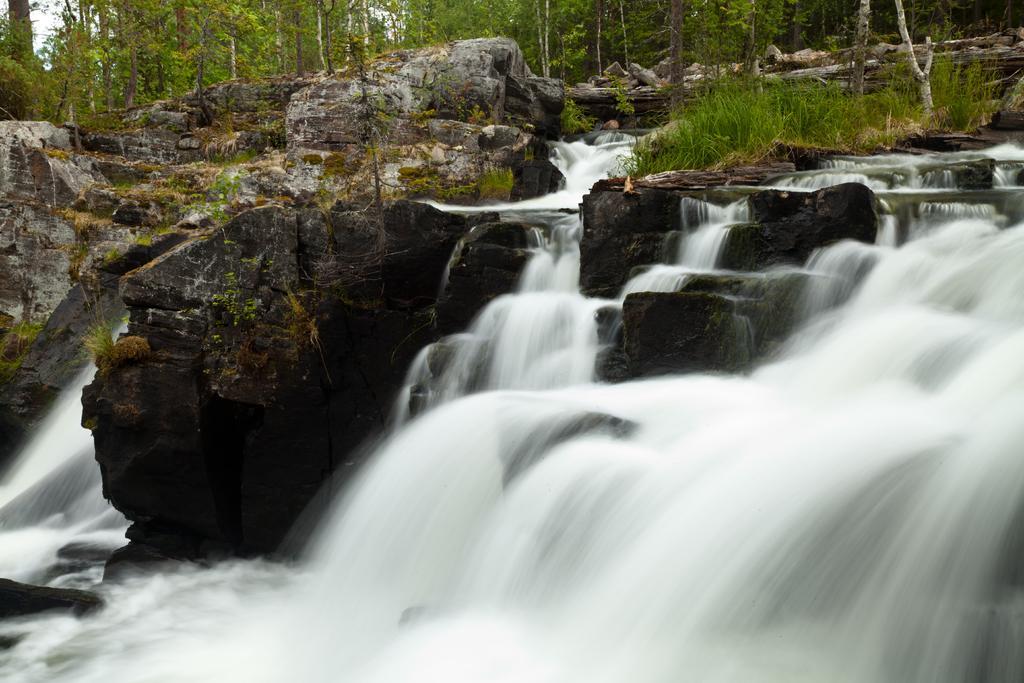Can you describe this image briefly? In this image we can see the waterfalls. We can also see the rocks and also trees and grass. 